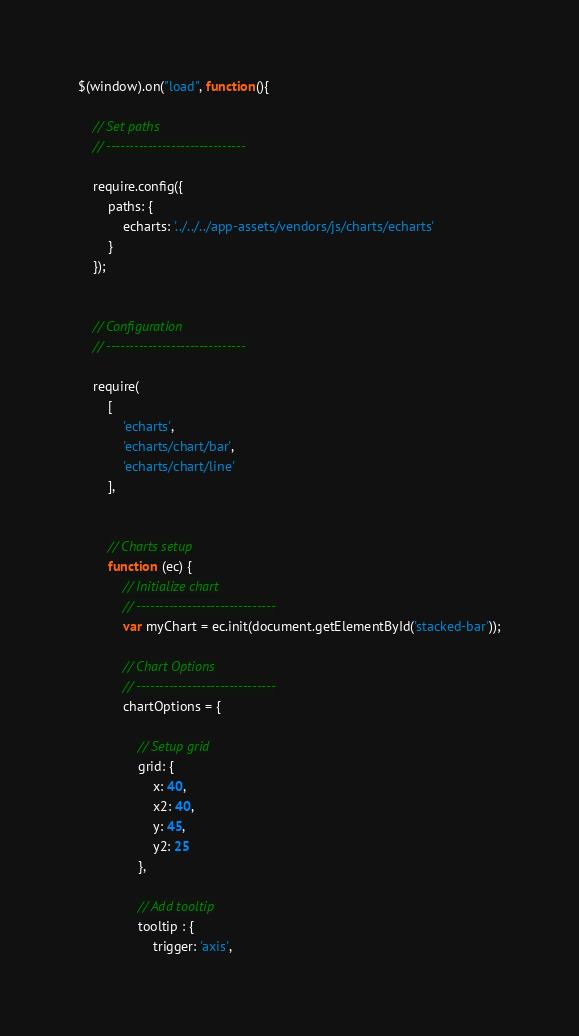<code> <loc_0><loc_0><loc_500><loc_500><_JavaScript_>$(window).on("load", function(){

    // Set paths
    // ------------------------------

    require.config({
        paths: {
            echarts: '../../../app-assets/vendors/js/charts/echarts'
        }
    });


    // Configuration
    // ------------------------------

    require(
        [
            'echarts',
            'echarts/chart/bar',
            'echarts/chart/line'
        ],


        // Charts setup
        function (ec) {
            // Initialize chart
            // ------------------------------
            var myChart = ec.init(document.getElementById('stacked-bar'));

            // Chart Options
            // ------------------------------
            chartOptions = {

                // Setup grid
                grid: {
                    x: 40,
                    x2: 40,
                    y: 45,
                    y2: 25
                },

                // Add tooltip
                tooltip : {
                    trigger: 'axis',</code> 